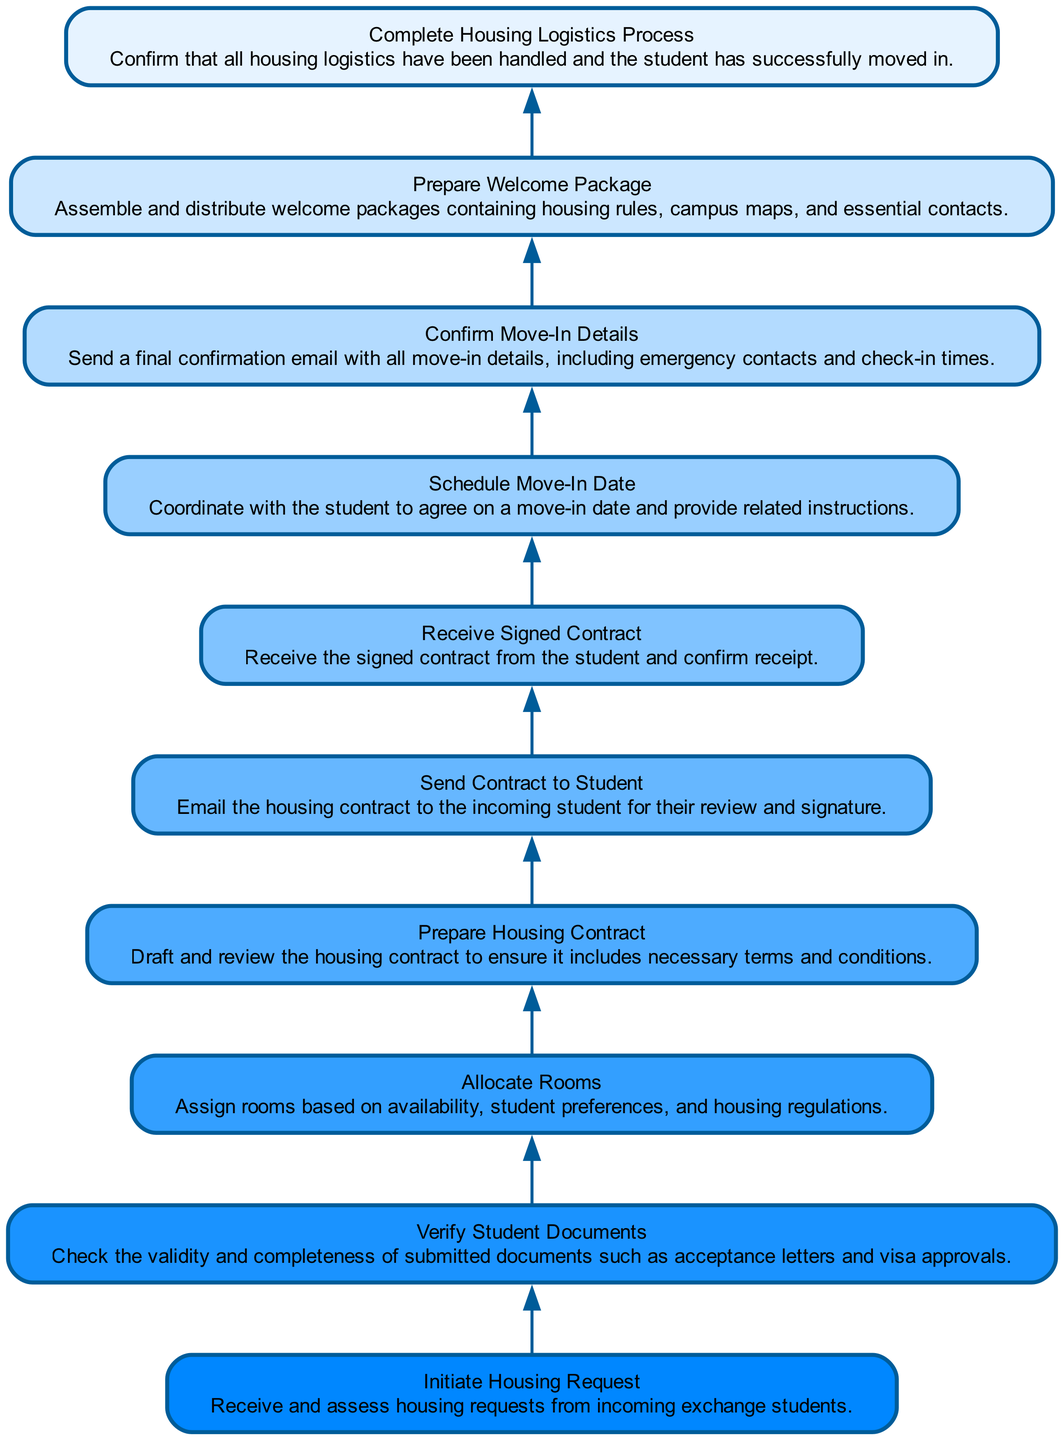What is the first step in handling student housing requests? The flow chart indicates that the first step is "Initiate Housing Request," which involves receiving and assessing requests from incoming exchange students.
Answer: Initiate Housing Request How many nodes are in the flow chart? By counting the elements listed in the diagram, there are ten nodes that represent different stages in the housing logistics process.
Answer: Ten What is the last step in the housing logistics process? The final node in the flow chart is "Complete Housing Logistics Process," confirming that all logistics have been handled and the student has moved in successfully.
Answer: Complete Housing Logistics Process Which step follows the "Send Contract to Student"? The diagram shows that the step following "Send Contract to Student" is "Receive Signed Contract," indicating the receipt and confirmation of the signed contract from the student.
Answer: Receive Signed Contract What document needs to be verified after initiating the housing request? After "Initiate Housing Request," the next step in the flow is to "Verify Student Documents," where the validity and completeness of documents such as acceptance letters and visa approvals are checked.
Answer: Verify Student Documents What is included in the "Prepare Welcome Package"? While the diagram does not specify all contents, it notes that the "Prepare Welcome Package" contains housing rules, campus maps, and essential contacts, all of which are grouped for the incoming students.
Answer: Housing rules, campus maps, and essential contacts How many edges are there in the flow chart? Counting the flow connections between nodes shows there are nine edges indicating the direction of the process from one step to the next.
Answer: Nine What action is taken after receiving the signed contract? Following the receipt of the signed contract, the next action is to "Schedule Move-In Date," which means coordinating with the student on when they will move into their housing.
Answer: Schedule Move-In Date What step is responsible for sending emergency contacts? The "Confirm Move-In Details" step is responsible for sending a final confirmation email, which includes emergency contacts and check-in times before the student moves in.
Answer: Confirm Move-In Details 